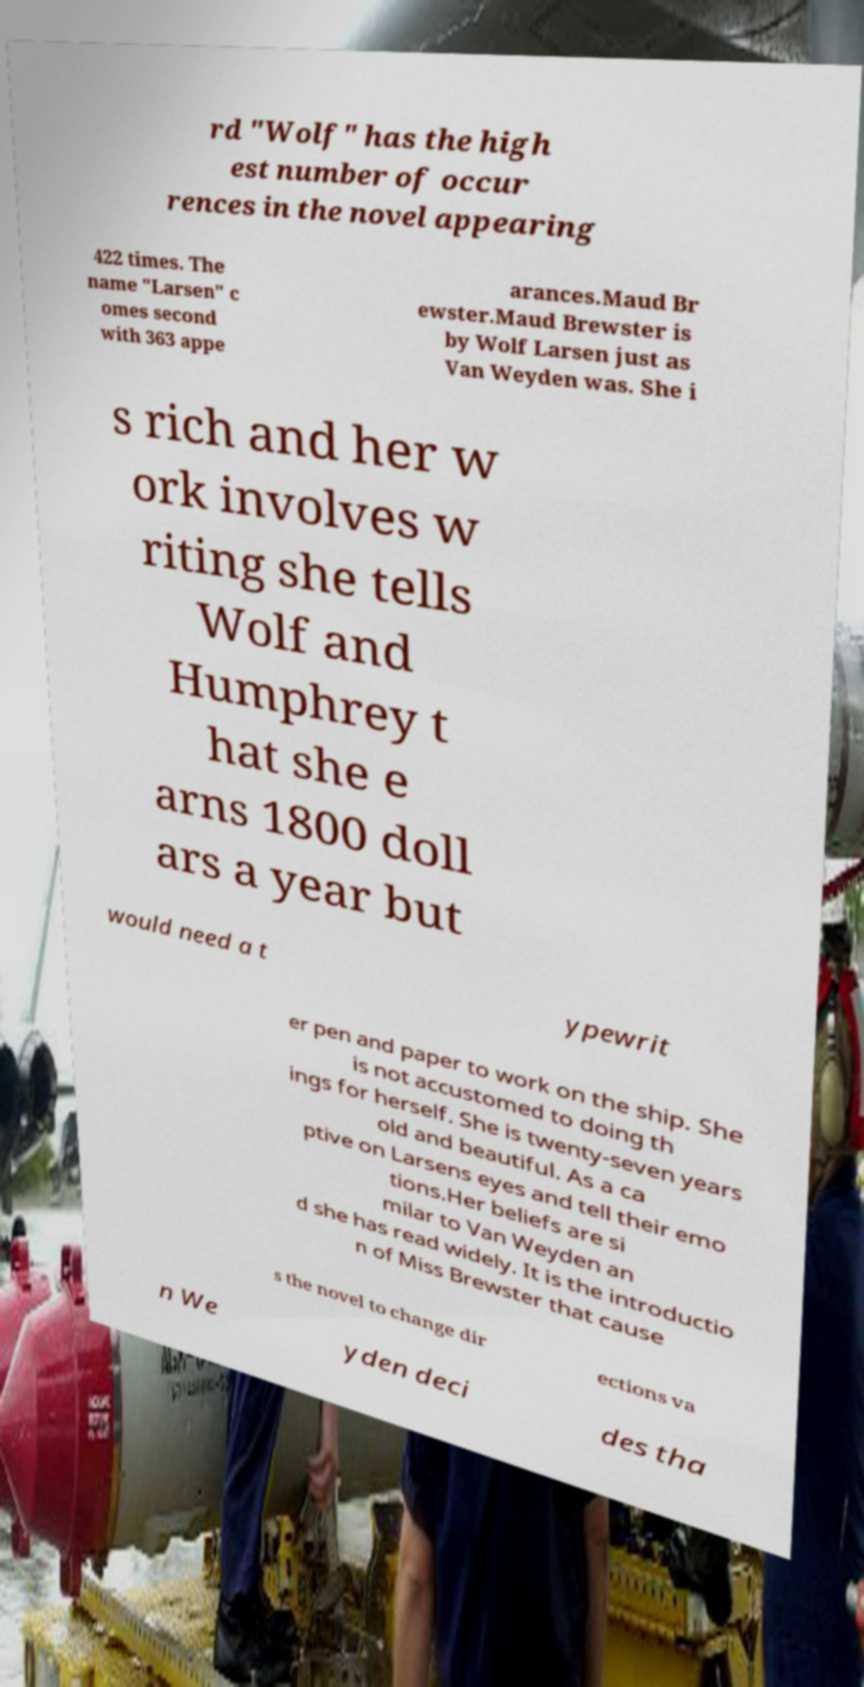Can you accurately transcribe the text from the provided image for me? rd "Wolf" has the high est number of occur rences in the novel appearing 422 times. The name "Larsen" c omes second with 363 appe arances.Maud Br ewster.Maud Brewster is by Wolf Larsen just as Van Weyden was. She i s rich and her w ork involves w riting she tells Wolf and Humphrey t hat she e arns 1800 doll ars a year but would need a t ypewrit er pen and paper to work on the ship. She is not accustomed to doing th ings for herself. She is twenty-seven years old and beautiful. As a ca ptive on Larsens eyes and tell their emo tions.Her beliefs are si milar to Van Weyden an d she has read widely. It is the introductio n of Miss Brewster that cause s the novel to change dir ections va n We yden deci des tha 